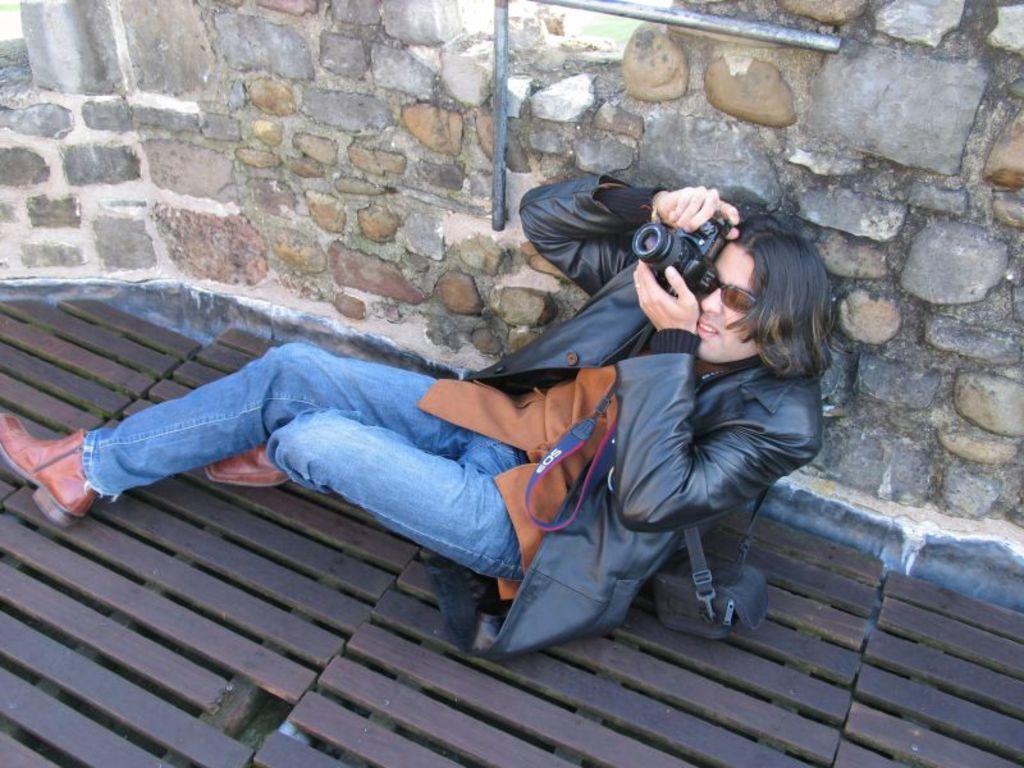Can you describe this image briefly? In this image, we can see a person sitting and holding camera in his hands. In the background, there is wall. At the bottom, there is wood. 